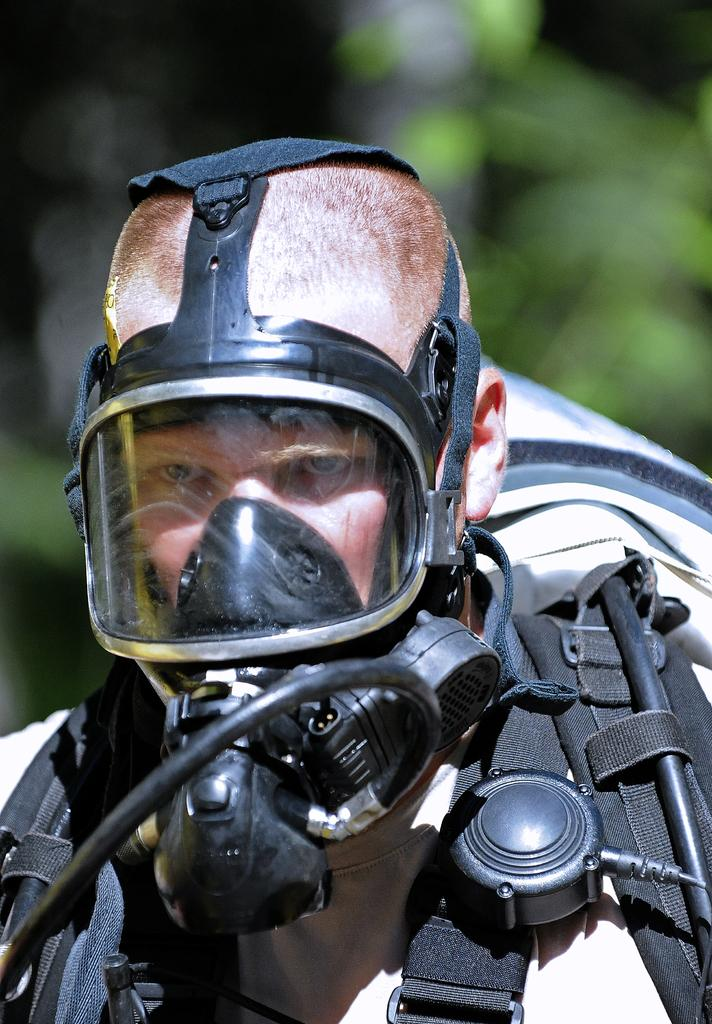Who is the main subject in the image? There is a person in the center of the image. What is the person wearing? The person is wearing a suit. Can you describe the background of the image? The background of the image is blurry. What type of milk is being poured into the person's coffee in the image? There is no coffee or milk present in the image; it only features a person wearing a suit with a blurry background. 